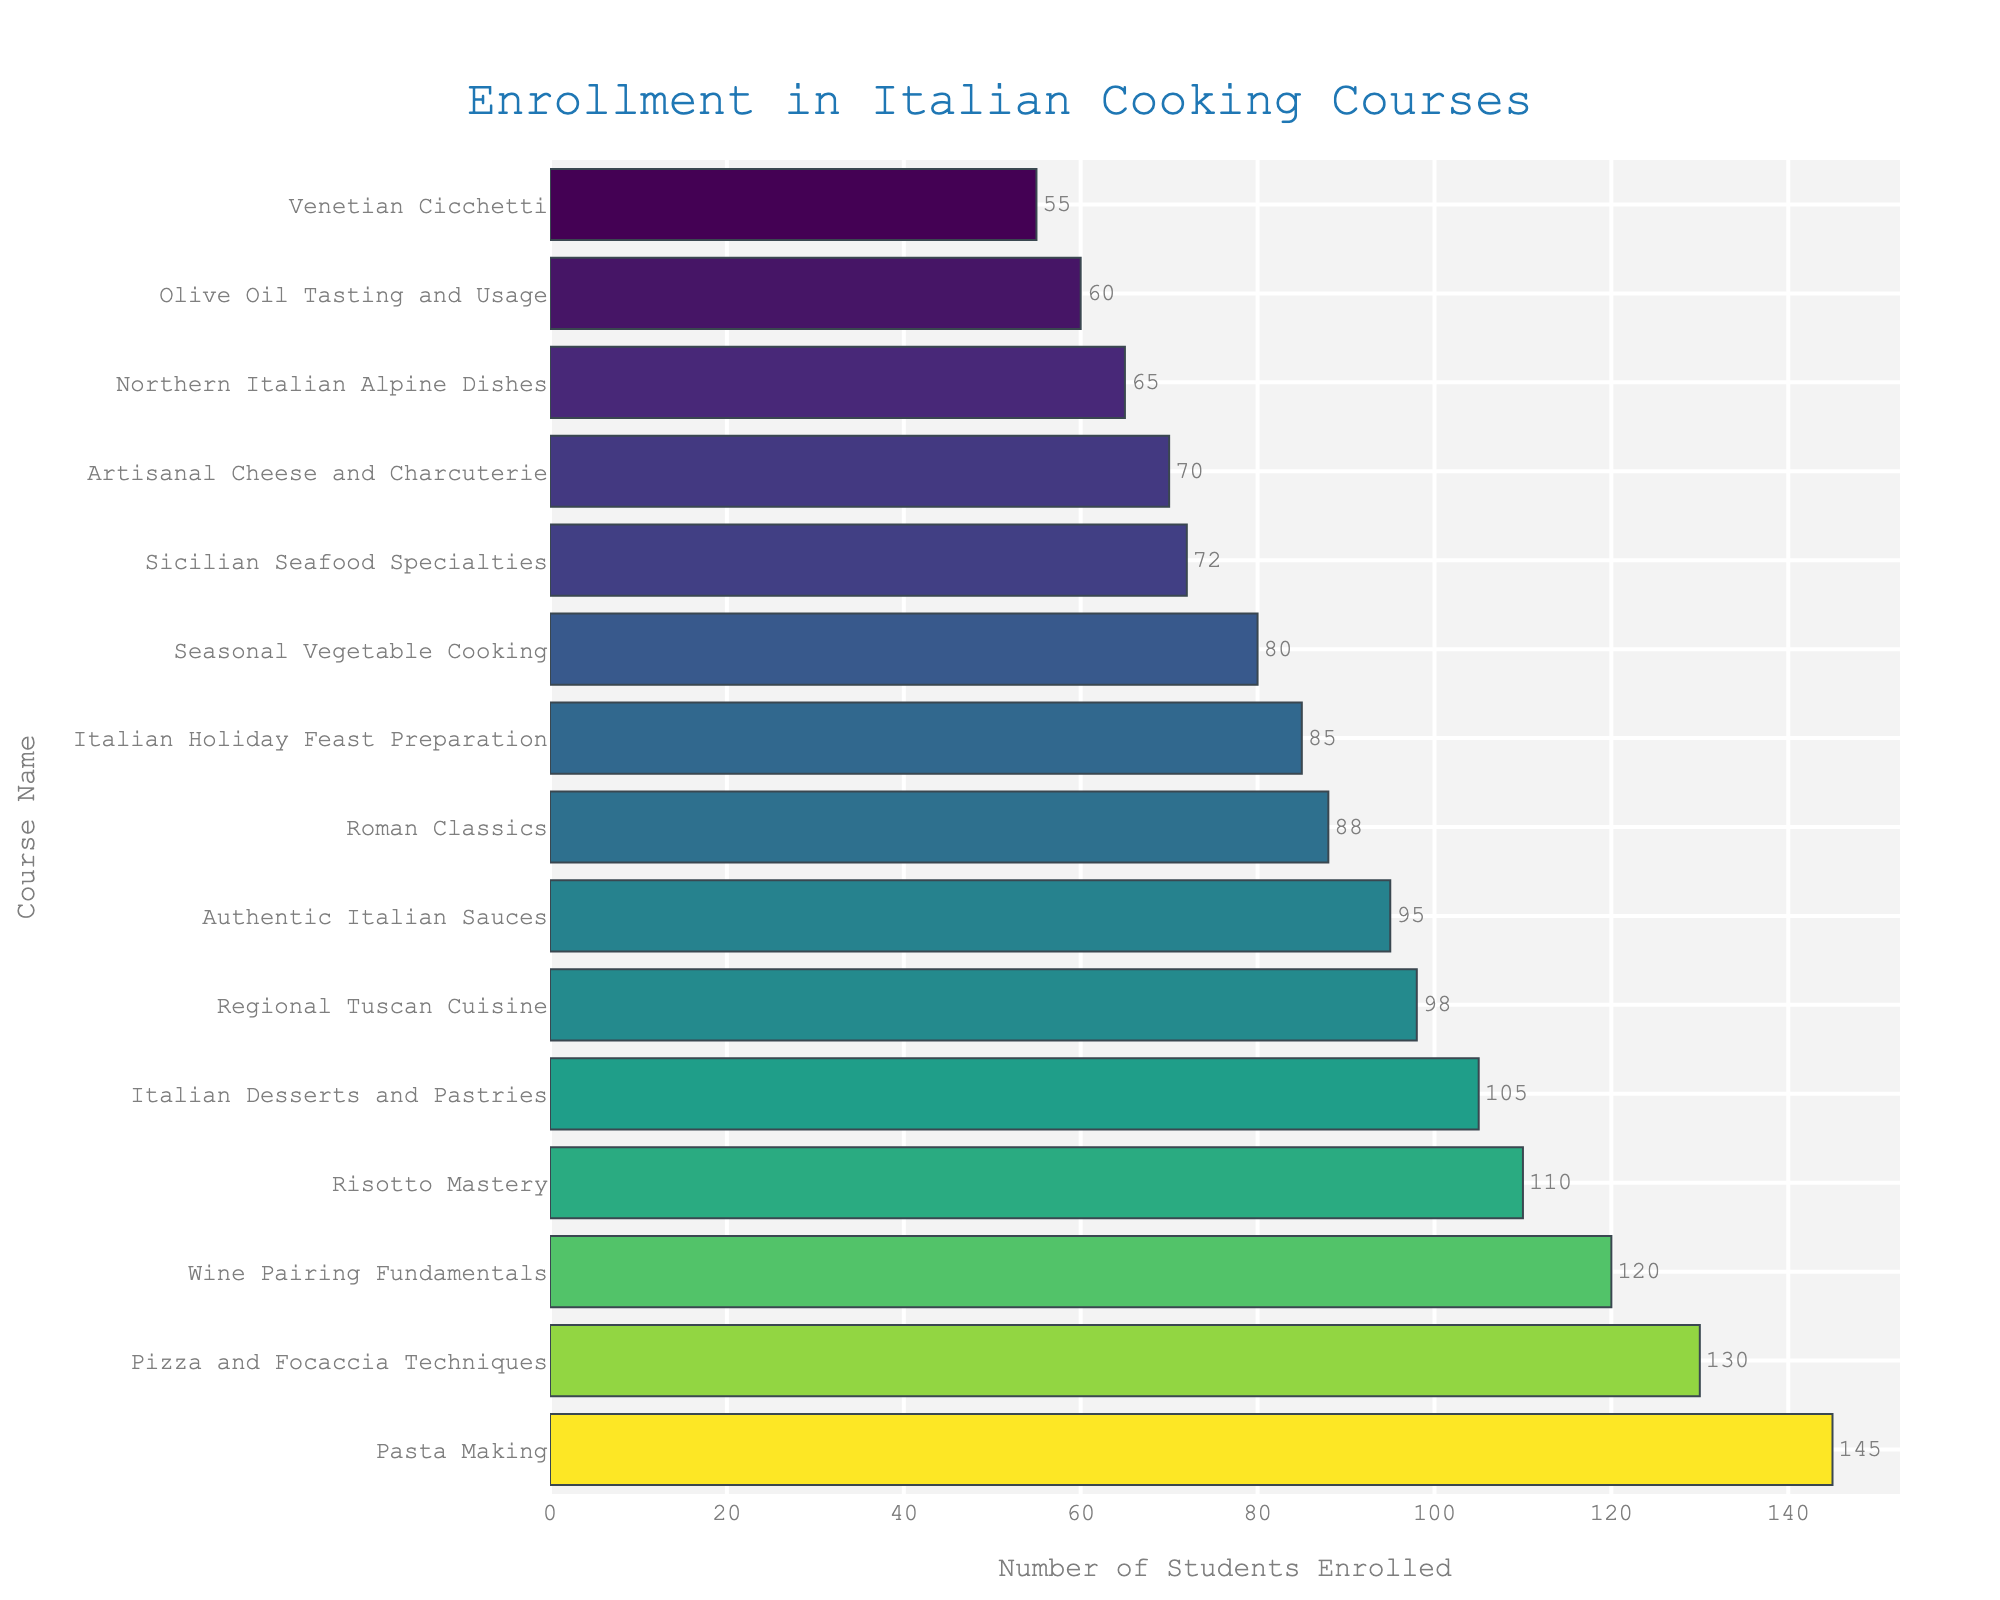Which course has the highest enrollment? The highest bar in the chart represents "Pasta Making" with an enrollment of 145 students.
Answer: Pasta Making Which course has the lowest enrollment? The shortest bar in the chart represents "Venetian Cicchetti" with an enrollment of 55 students.
Answer: Venetian Cicchetti What is the difference in enrollment between "Wine Pairing Fundamentals" and "Regional Tuscan Cuisine"? "Wine Pairing Fundamentals" enrolls 120 students and "Regional Tuscan Cuisine" enrolls 98 students. The difference is 120 - 98.
Answer: 22 What is the total enrollment for "Pasta Making", "Risotto Mastery", and "Pizza and Focaccia Techniques"? The enrollments are 145 for "Pasta Making", 110 for "Risotto Mastery", and 130 for "Pizza and Focaccia Techniques". The total sum is 145 + 110 + 130.
Answer: 385 Which courses have enrollments that are greater than 100 but less than 130? By observing the chart, the courses with enrollments in this range are "Risotto Mastery" (110), "Italian Desserts and Pastries" (105), and "Wine Pairing Fundamentals" (120).
Answer: Risotto Mastery, Italian Desserts and Pastries, Wine Pairing Fundamentals How many courses have enrollments below 80 students? The bars indicating enrollments below 80 are "Sicilian Seafood Specialties" (72), "Northern Italian Alpine Dishes" (65), "Venetian Cicchetti" (55), "Artisanal Cheese and Charcuterie" (70), and "Olive Oil Tasting and Usage" (60). There are 5 such courses.
Answer: 5 What is the total enrollment for all courses? Adding all the enrollments: 145 + 98 + 72 + 110 + 130 + 65 + 88 + 55 + 105 + 120 + 95 + 80 + 70 + 60 + 85. The sum is 1378.
Answer: 1378 What is the average enrollment across all courses? First, obtain the total enrollment which is 1378. There are 15 courses. The average is 1378 / 15.
Answer: 91.87 